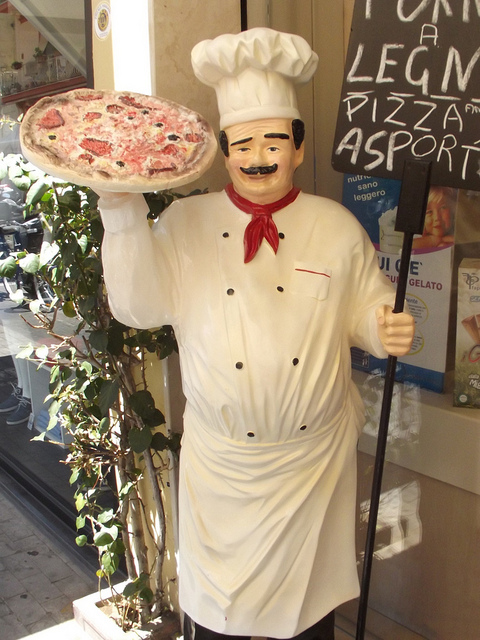This statue looks quirky. What can you tell me about its design? The statue's design is both charming and typical of an advertisement for an Italian eatery. It portrays a stereotypical chef with features like a tall white hat, white double-breasted jacket, and a wide smile, all of which aim to convey a sense of authenticity and welcome to potential customers. Does this type of statue have a name or a specific purpose? Such statues are often colloquially known as 'mascots' or 'advertising figures.' They serve a dual purpose: to attract the attention of passersby and to instantly communicate the kind of food the establishment serves, in this case, pizza. 